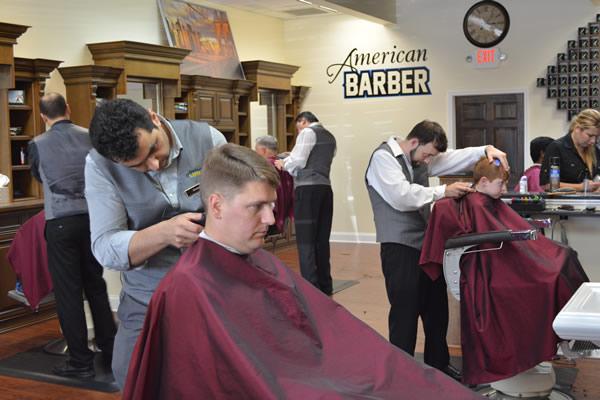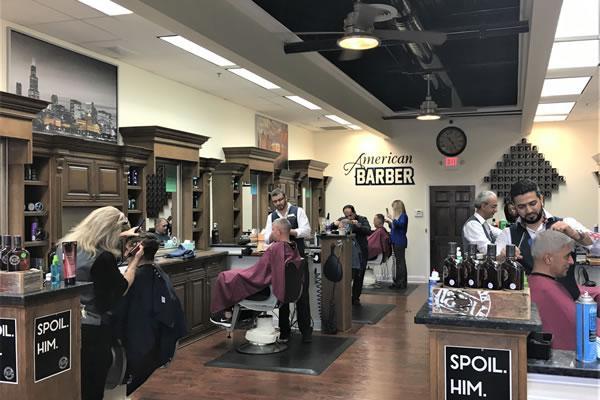The first image is the image on the left, the second image is the image on the right. Considering the images on both sides, is "There are at least three people in red capes getting there hair cut." valid? Answer yes or no. Yes. 